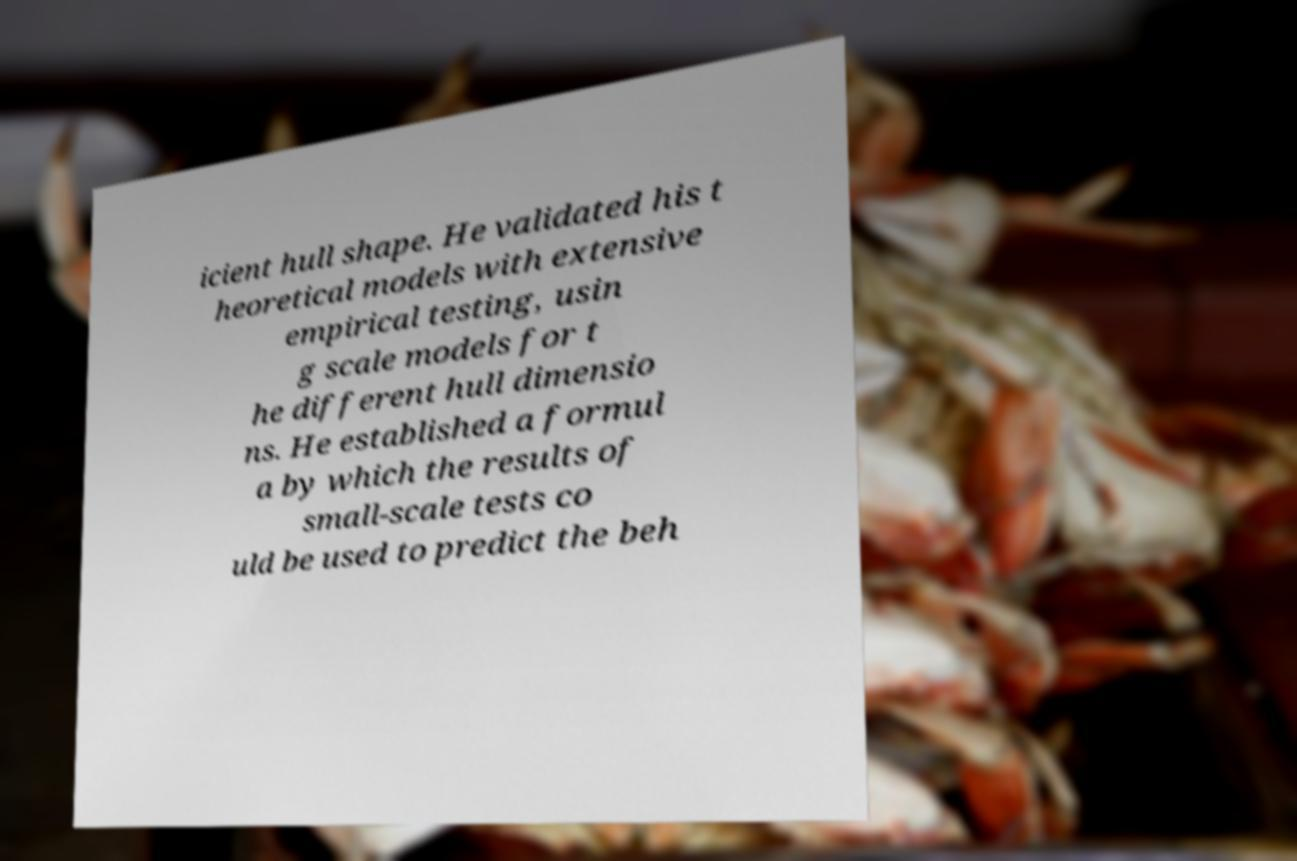Could you assist in decoding the text presented in this image and type it out clearly? icient hull shape. He validated his t heoretical models with extensive empirical testing, usin g scale models for t he different hull dimensio ns. He established a formul a by which the results of small-scale tests co uld be used to predict the beh 